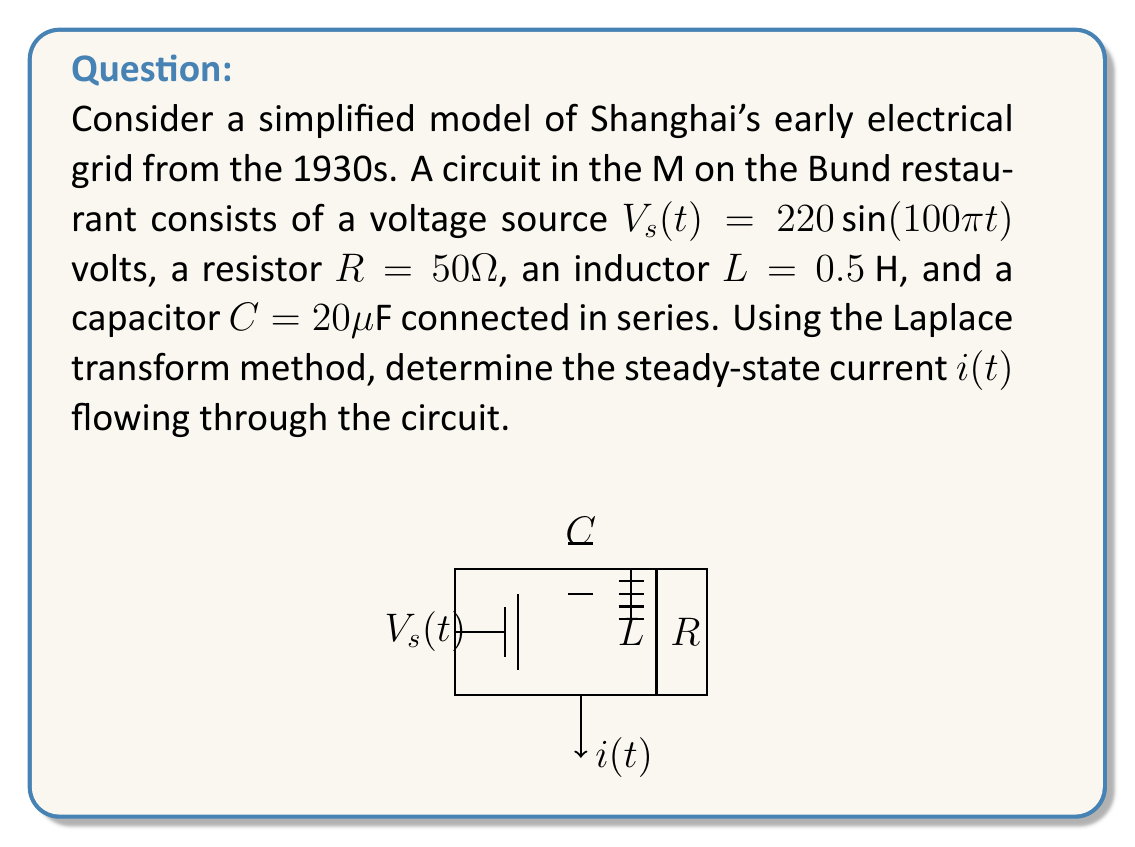Provide a solution to this math problem. Let's solve this problem step by step using the Laplace transform method:

1) First, we'll write the differential equation for the circuit:

   $$L\frac{di}{dt} + Ri + \frac{1}{C}\int i dt = V_s(t)$$

2) Taking the Laplace transform of both sides:

   $$L[sI(s) - i(0)] + RI(s) + \frac{1}{Cs}I(s) = \frac{220s}{s^2 + (100\pi)^2}$$

   Assuming zero initial conditions, $i(0) = 0$.

3) Simplifying:

   $$I(s)[Ls + R + \frac{1}{Cs}] = \frac{220s}{s^2 + (100\pi)^2}$$

4) Solving for $I(s)$:

   $$I(s) = \frac{220s}{(s^2 + (100\pi)^2)(Ls + R + \frac{1}{Cs})}$$

5) Substituting the given values:

   $$I(s) = \frac{220s}{(s^2 + (100\pi)^2)(0.5s + 50 + \frac{1}{20\times10^{-6}s})}$$

6) Simplifying:

   $$I(s) = \frac{220s}{(s^2 + (100\pi)^2)(0.5s + 50 + \frac{50000}{s})}$$

7) For steady-state response, we're only interested in the particular solution, which corresponds to the poles of the input. These are at $s = \pm j100\pi$. Evaluating $I(s)$ at $s = j100\pi$:

   $$I(j100\pi) = \frac{220j100\pi}{(j100\pi)^2 + (100\pi)^2} \cdot \frac{1}{0.5j100\pi + 50 + \frac{50000}{j100\pi}}$$

8) Simplifying:

   $$I(j100\pi) = \frac{220j100\pi}{2(100\pi)^2} \cdot \frac{1}{50 + j50\pi - j\frac{500}{\pi}} = \frac{1.1}{50 + j(50\pi - \frac{500}{\pi})}$$

9) Converting to polar form:

   $$I(j100\pi) = \frac{1.1}{\sqrt{50^2 + (50\pi - \frac{500}{\pi})^2}} \angle -\tan^{-1}(\frac{50\pi - \frac{500}{\pi}}{50})$$

10) The steady-state current will be:

    $$i(t) = |I(j100\pi)| \sin(100\pi t + \angle I(j100\pi))$$
Answer: The steady-state current is:

$$i(t) = \frac{1.1}{\sqrt{50^2 + (50\pi - \frac{500}{\pi})^2}} \sin(100\pi t - \tan^{-1}(\frac{50\pi - \frac{500}{\pi}}{50})) \text{ A}$$

Numerically, this is approximately:

$$i(t) = 0.0697 \sin(100\pi t - 1.254) \text{ A}$$ 